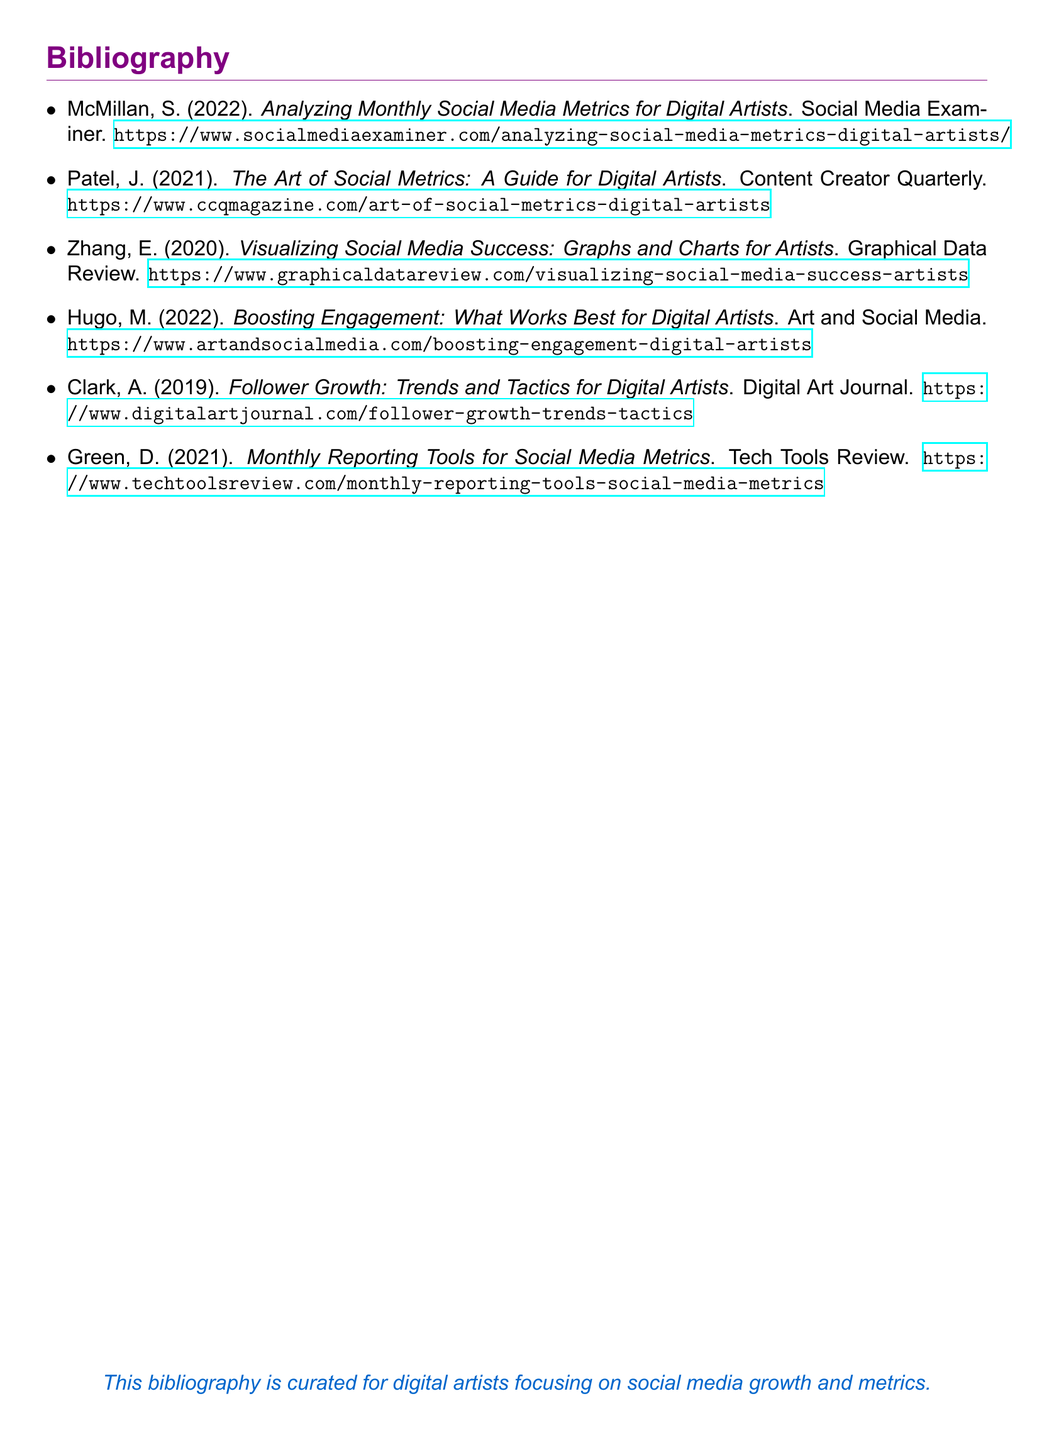What is the title of the first resource listed? The title of the first resource is indicated at the top of the first bibliographic entry in the document.
Answer: Analyzing Monthly Social Media Metrics for Digital Artists Who is the author of the second resource? The author of the second resource can be found next to the title in the bibliography.
Answer: J. Patel In what year was the resource by Zhang published? The publication year is included at the end of the bibliographic entry for Zhang's resource.
Answer: 2020 Which URL belongs to the resource focusing on boosting engagement? The URL corresponding to boosting engagement is listed after the title and author's name in the entry for that topic.
Answer: https://www.artandsocialmedia.com/boosting-engagement-digital-artists How many total bibliographic entries are in the document? The total number of entries can be counted from the list provided in the bibliography section.
Answer: 6 Which color is used for section titles in this document? The color used for section titles is mentioned in the document formatting commands.
Answer: artistpurple What is the main purpose of this bibliography? The purpose is stated in the last line of the document with a brief summary.
Answer: Focus on social media growth and metrics What type of publication is "Content Creator Quarterly"? The type of publication is implied by the context of the entries in the bibliography.
Answer: Magazine 